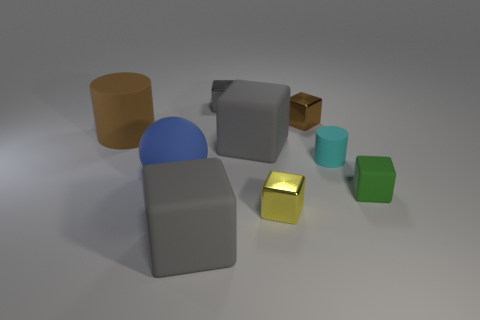How many gray cubes must be subtracted to get 1 gray cubes? 2 Subtract all yellow metal cubes. How many cubes are left? 5 Subtract all brown cylinders. How many cylinders are left? 1 Subtract 1 balls. How many balls are left? 0 Add 1 large blue rubber spheres. How many objects exist? 10 Subtract all spheres. How many objects are left? 8 Add 9 cyan things. How many cyan things exist? 10 Subtract 0 yellow balls. How many objects are left? 9 Subtract all gray cylinders. Subtract all gray balls. How many cylinders are left? 2 Subtract all cyan blocks. How many green cylinders are left? 0 